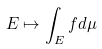<formula> <loc_0><loc_0><loc_500><loc_500>E \mapsto \int _ { E } f d \mu</formula> 